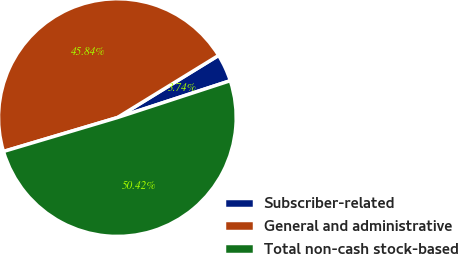Convert chart to OTSL. <chart><loc_0><loc_0><loc_500><loc_500><pie_chart><fcel>Subscriber-related<fcel>General and administrative<fcel>Total non-cash stock-based<nl><fcel>3.74%<fcel>45.84%<fcel>50.42%<nl></chart> 